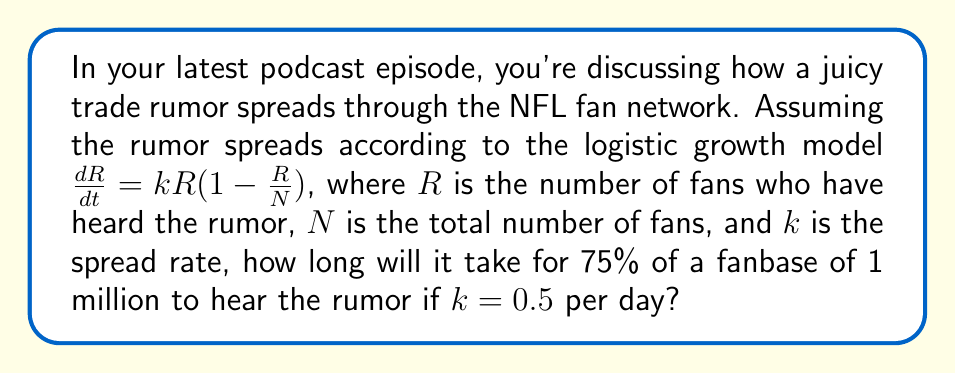Give your solution to this math problem. Let's approach this step-by-step:

1) The logistic growth model is given by:

   $$\frac{dR}{dt} = kR(1-\frac{R}{N})$$

2) We're asked to find the time when 75% of the fanbase has heard the rumor. This means:

   $R = 0.75N = 750,000$ (since $N = 1,000,000$)

3) The solution to the logistic equation is:

   $$R(t) = \frac{N}{1 + (\frac{N}{R_0} - 1)e^{-kt}}$$

   Where $R_0$ is the initial number of people who have heard the rumor.

4) Let's assume $R_0 = 1$ (the person who started the rumor).

5) Substituting our values:

   $$750,000 = \frac{1,000,000}{1 + (1,000,000 - 1)e^{-0.5t}}$$

6) Simplifying:

   $$0.75 = \frac{1}{1 + 999,999e^{-0.5t}}$$

7) Solving for $t$:

   $$\frac{1}{0.75} = 1 + 999,999e^{-0.5t}$$
   $$\frac{4}{3} - 1 = 999,999e^{-0.5t}$$
   $$\frac{1}{3} = 999,999e^{-0.5t}$$
   $$\frac{1}{2,999,997} = e^{-0.5t}$$
   $$\ln(\frac{1}{2,999,997}) = -0.5t$$
   $$t = \frac{2\ln(2,999,997)}{0.5} \approx 29.84$$

Therefore, it will take approximately 29.84 days for 75% of the fanbase to hear the rumor.
Answer: 29.84 days 